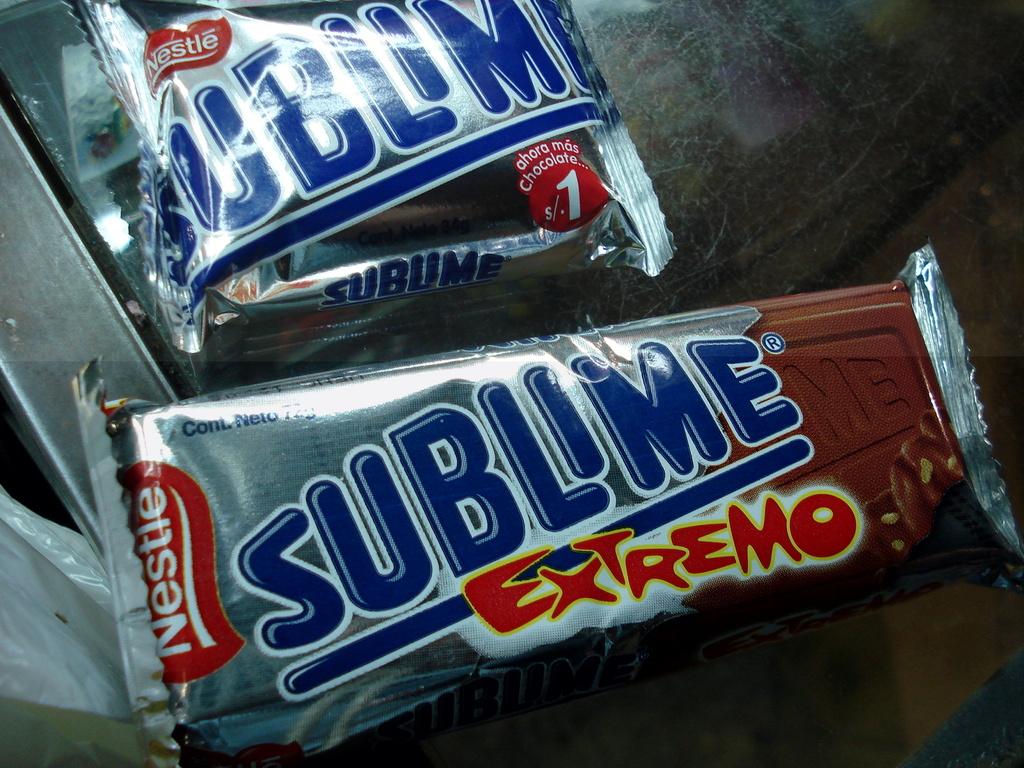What type of sublime is it?
Keep it short and to the point. Extremo. What brand of ice cream is this?
Your answer should be compact. Nestle. 